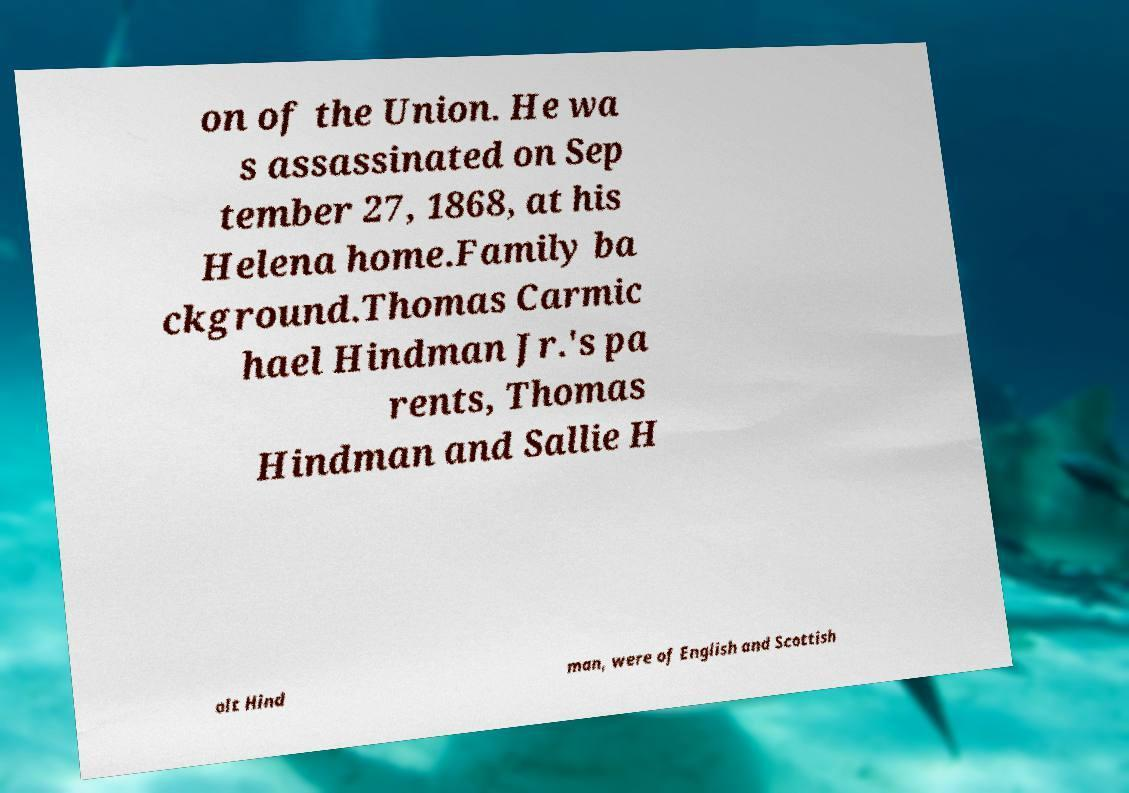Can you accurately transcribe the text from the provided image for me? on of the Union. He wa s assassinated on Sep tember 27, 1868, at his Helena home.Family ba ckground.Thomas Carmic hael Hindman Jr.'s pa rents, Thomas Hindman and Sallie H olt Hind man, were of English and Scottish 